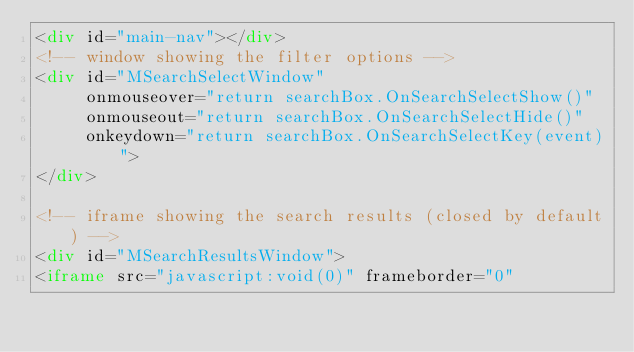<code> <loc_0><loc_0><loc_500><loc_500><_HTML_><div id="main-nav"></div>
<!-- window showing the filter options -->
<div id="MSearchSelectWindow"
     onmouseover="return searchBox.OnSearchSelectShow()"
     onmouseout="return searchBox.OnSearchSelectHide()"
     onkeydown="return searchBox.OnSearchSelectKey(event)">
</div>

<!-- iframe showing the search results (closed by default) -->
<div id="MSearchResultsWindow">
<iframe src="javascript:void(0)" frameborder="0" </code> 